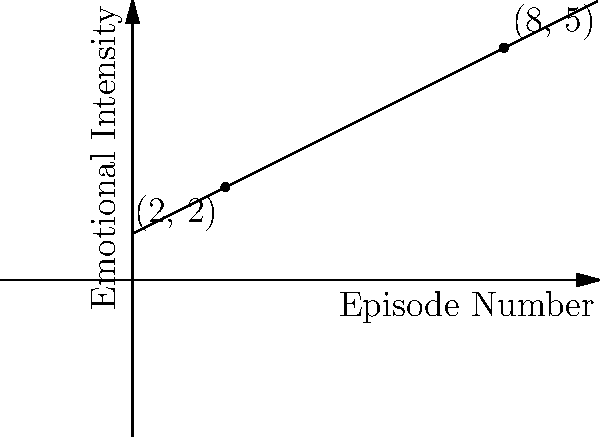In the popular '90s teen drama "Heartbreak High", the graph represents the emotional journey of Drazic throughout Season 3. Each point on the line corresponds to an episode, with the x-axis representing the episode number and the y-axis representing the emotional intensity on a scale of 1-10. Given the points (2, 2) and (8, 5) on this line, determine the slope of Drazic's emotional journey. What does this slope indicate about his character development? To find the slope of Drazic's emotional journey, we'll use the slope formula:

$$ m = \frac{y_2 - y_1}{x_2 - x_1} $$

Where $(x_1, y_1)$ is the first point and $(x_2, y_2)$ is the second point.

Step 1: Identify the coordinates
$(x_1, y_1) = (2, 2)$
$(x_2, y_2) = (8, 5)$

Step 2: Plug the values into the slope formula
$$ m = \frac{5 - 2}{8 - 2} = \frac{3}{6} = 0.5 $$

Step 3: Interpret the result
The slope is 0.5, which means for every episode (x-axis unit), Drazic's emotional intensity increases by 0.5 units on average.

This positive slope indicates that Drazic's character is experiencing gradual emotional growth or intensification throughout the season. It suggests a consistent upward trend in his emotional state, which could reflect character development, increasing conflicts, or deepening relationships as the season progresses.
Answer: Slope = 0.5; indicates gradual, consistent emotional intensification 